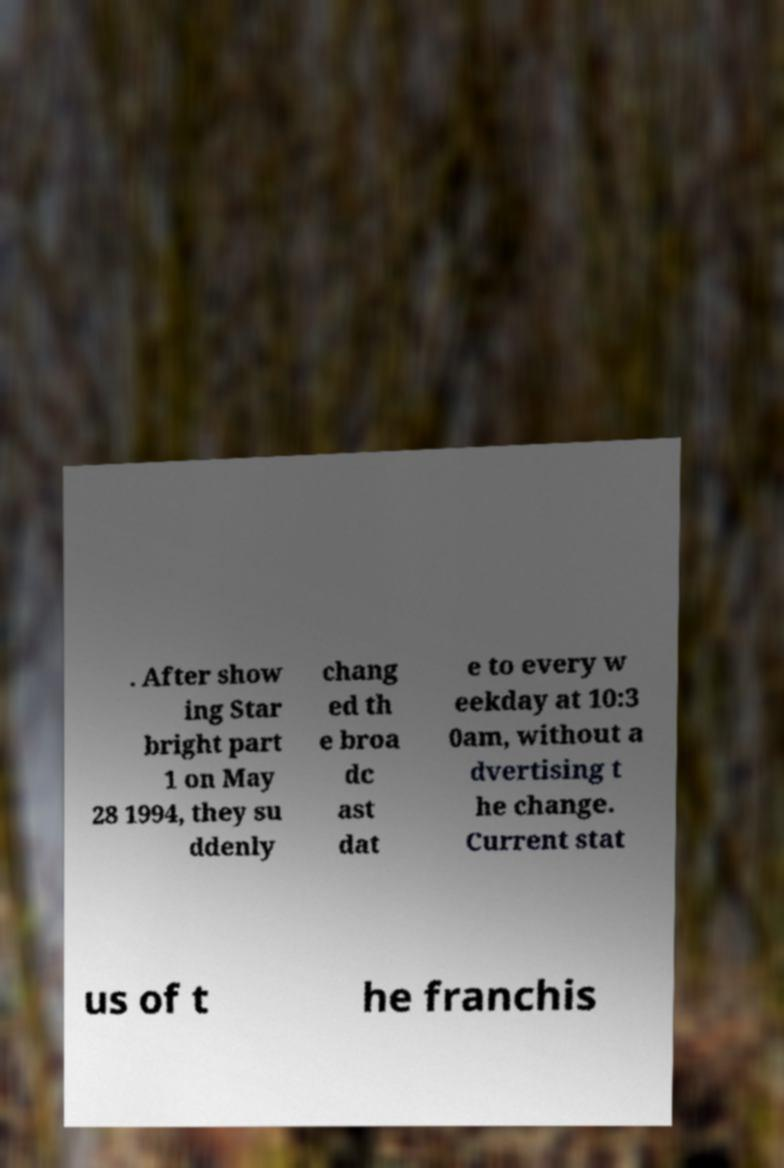I need the written content from this picture converted into text. Can you do that? . After show ing Star bright part 1 on May 28 1994, they su ddenly chang ed th e broa dc ast dat e to every w eekday at 10:3 0am, without a dvertising t he change. Current stat us of t he franchis 